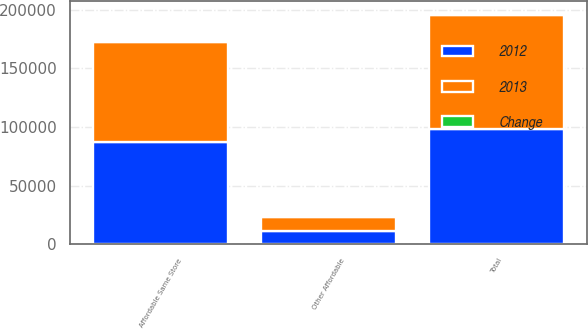Convert chart to OTSL. <chart><loc_0><loc_0><loc_500><loc_500><stacked_bar_chart><ecel><fcel>Affordable Same Store<fcel>Other Affordable<fcel>Total<nl><fcel>2012<fcel>87047<fcel>11666<fcel>98713<nl><fcel>2013<fcel>85522<fcel>11613<fcel>97135<nl><fcel>Change<fcel>1525<fcel>53<fcel>1578<nl></chart> 